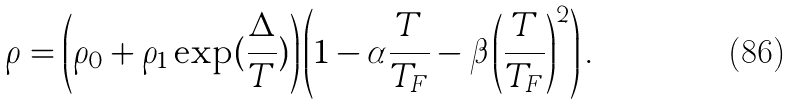<formula> <loc_0><loc_0><loc_500><loc_500>\rho = \left ( \rho _ { 0 } + \rho _ { 1 } \exp ( \frac { \Delta } { T } ) \right ) \left ( 1 - \alpha \frac { T } { T _ { F } } - \beta \left ( \frac { T } { T _ { F } } \right ) ^ { 2 } \right ) .</formula> 